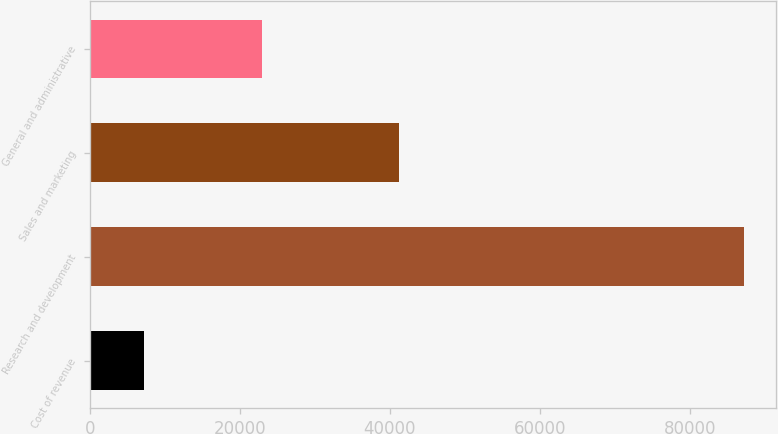Convert chart. <chart><loc_0><loc_0><loc_500><loc_500><bar_chart><fcel>Cost of revenue<fcel>Research and development<fcel>Sales and marketing<fcel>General and administrative<nl><fcel>7165<fcel>87163<fcel>41227<fcel>22972<nl></chart> 